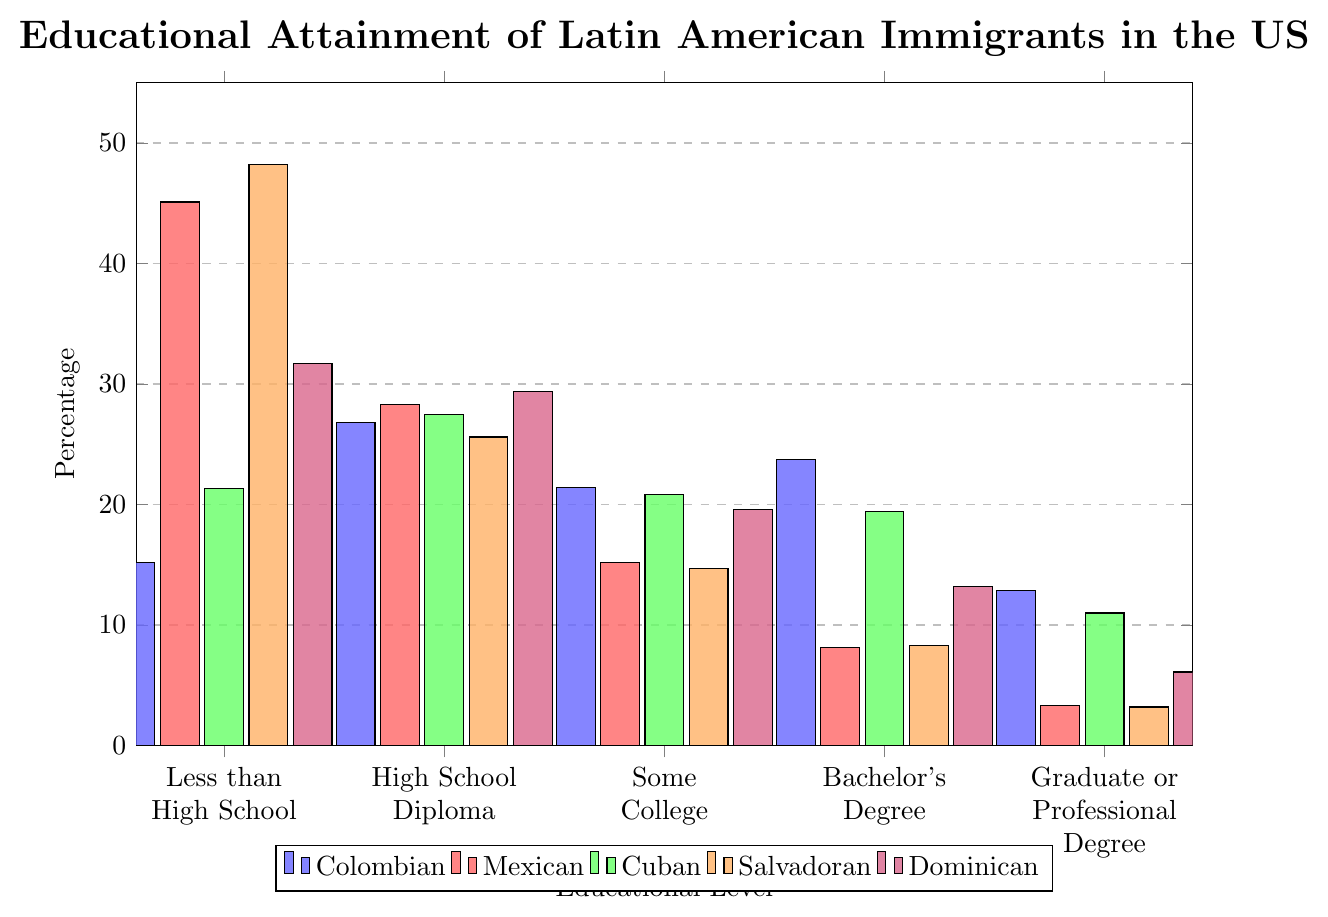Which educational attainment level has the highest percentage of Colombian immigrants? Look at the data for the highest bar among Colombian immigrants. The Bachelor's Degree level has the highest percentage at 23.7%.
Answer: Bachelor's Degree What is the difference in percentage between Colombian and Mexican immigrants with a Graduate or Professional Degree? Subtract the percentage of Mexican immigrants in this educational category from that of Colombian immigrants. The difference is 12.9% - 3.3% = 9.6%.
Answer: 9.6% Compare the percentage of Salvadoran immigrants with a High School Diploma to Colombian immigrants with the same qualification. Which group has a higher percentage? Compare the two percentages: Salvadoran immigrants at 25.6% and Colombian immigrants at 26.8%. Colombian immigrants have a higher percentage.
Answer: Colombian immigrants Which immigrant group has the highest percentage of individuals who completed less than a high school education? Look at the bar heights for all groups in the "Less than High School" category. Salvadoran immigrants show the highest percentage at 48.2%.
Answer: Salvadoran immigrants What is the average percentage of Cuban immigrants across all educational attainment levels? Sum up the percentages of Cuban immigrants for all educational levels and divide by the number of categories: (21.3 + 27.5 + 20.8 + 19.4 + 11.0)/5 = 100/5 = 20%.
Answer: 20% Which immigrant group has the lowest percentage with a Bachelor's Degree? Compare the percentages in the "Bachelor's Degree" category for all groups. Mexican immigrants have the lowest percentage at 8.1%.
Answer: Mexican immigrants How does the percentage of Dominican immigrants with some college compare with Cuban immigrants with the same qualification? Compare the two percentages: Dominican immigrants at 19.6% and Cuban immigrants at 20.8%. Cuban immigrants have a slightly higher percentage.
Answer: Cuban immigrants What is the combined percentage of Colombian immigrants with either a Bachelor's Degree or a Graduate or Professional Degree? Add the percentages of Colombian immigrants in these two categories: 23.7% + 12.9% = 36.6%.
Answer: 36.6% Rank the immigrant groups from highest to lowest percentage of individuals with some college. Compare the percentages of all groups in "Some College": Colombian (21.4%), Mexican (15.2%), Cuban (20.8%), Salvadoran (14.7%), Dominican (19.6%). Ranking: Colombian, Cuban, Dominican, Mexican, Salvadoran.
Answer: Colombian, Cuban, Dominican, Mexican, Salvadoran What is the percentage difference between the highest and lowest educational attainment levels for Dominican immigrants? Subtract the percentage of Dominican immigrants with Graduate or Professional Degrees from those with less than a High School education: 31.7% - 6.1% = 25.6%.
Answer: 25.6% 